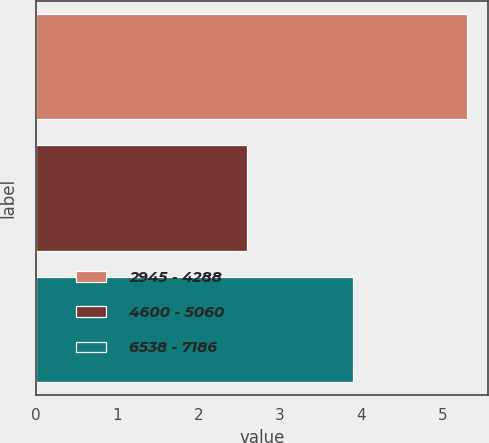Convert chart to OTSL. <chart><loc_0><loc_0><loc_500><loc_500><bar_chart><fcel>2945 - 4288<fcel>4600 - 5060<fcel>6538 - 7186<nl><fcel>5.3<fcel>2.6<fcel>3.9<nl></chart> 